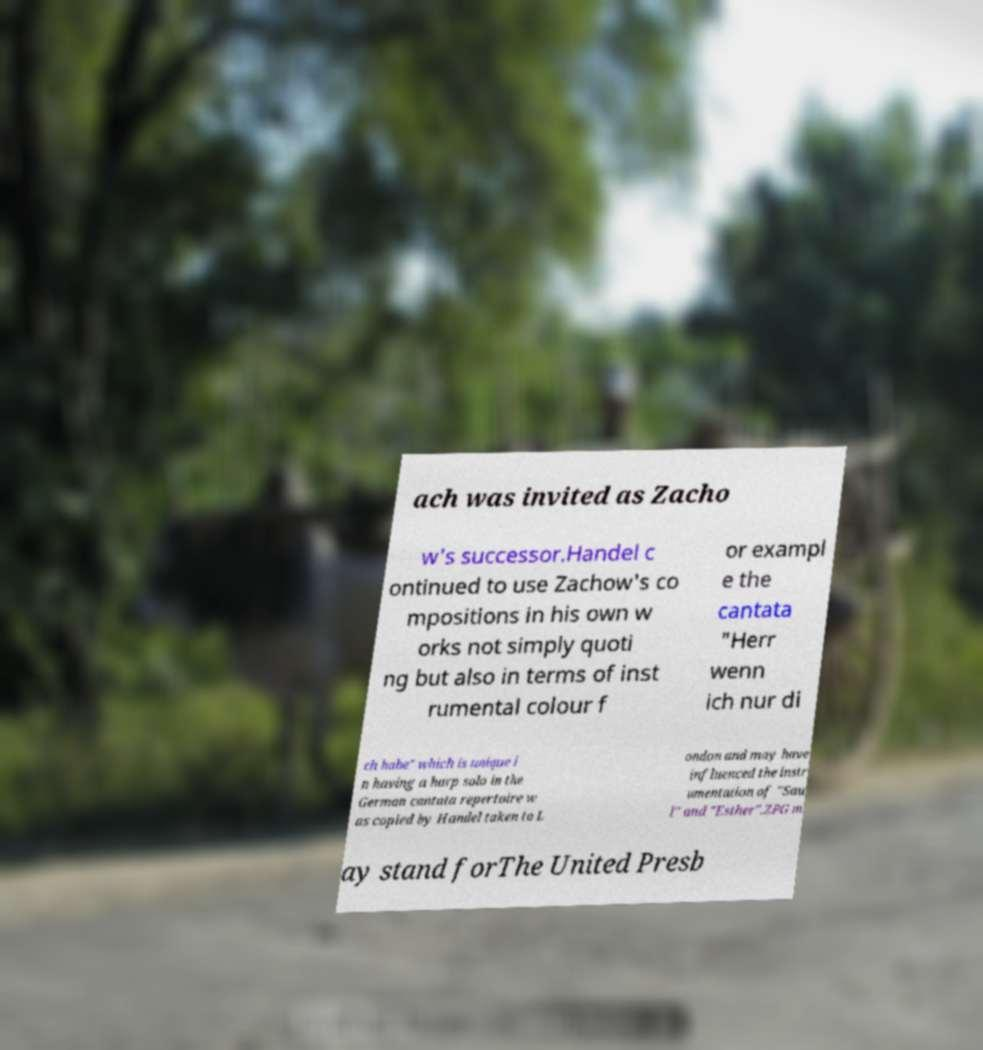Please read and relay the text visible in this image. What does it say? ach was invited as Zacho w's successor.Handel c ontinued to use Zachow's co mpositions in his own w orks not simply quoti ng but also in terms of inst rumental colour f or exampl e the cantata "Herr wenn ich nur di ch habe" which is unique i n having a harp solo in the German cantata repertoire w as copied by Handel taken to L ondon and may have influenced the instr umentation of "Sau l" and "Esther".ZPG m ay stand forThe United Presb 